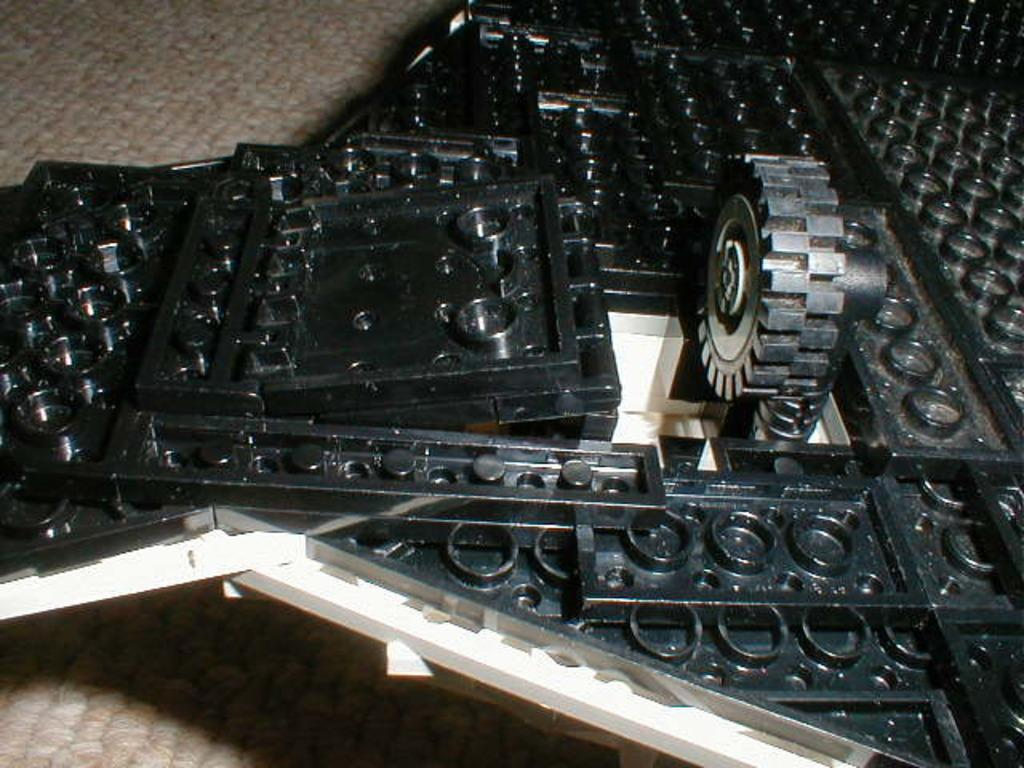What is the color of the frame in the image? The frame in the image is black. What object is present in the image besides the frame? There is a wheel in the image. What is the color of the surface on which the frame and wheel are placed? The surface is cream-colored. What type of silk fabric is draped over the wheel in the image? There is no silk fabric present in the image; the wheel is not draped with any fabric. 